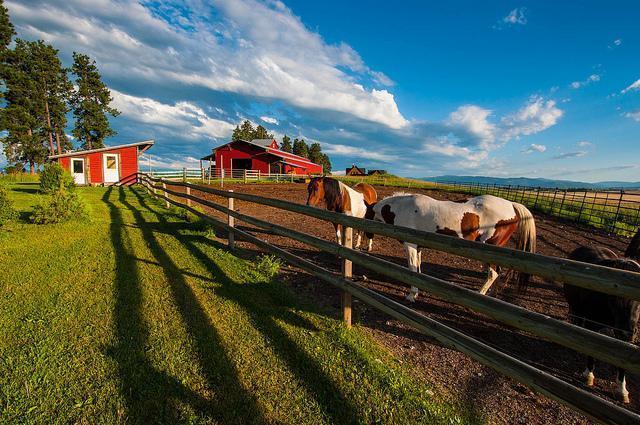How many horses can be seen?
Give a very brief answer. 3. 